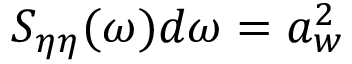Convert formula to latex. <formula><loc_0><loc_0><loc_500><loc_500>S _ { \eta \eta } ( \omega ) d \omega = a _ { w } ^ { 2 }</formula> 